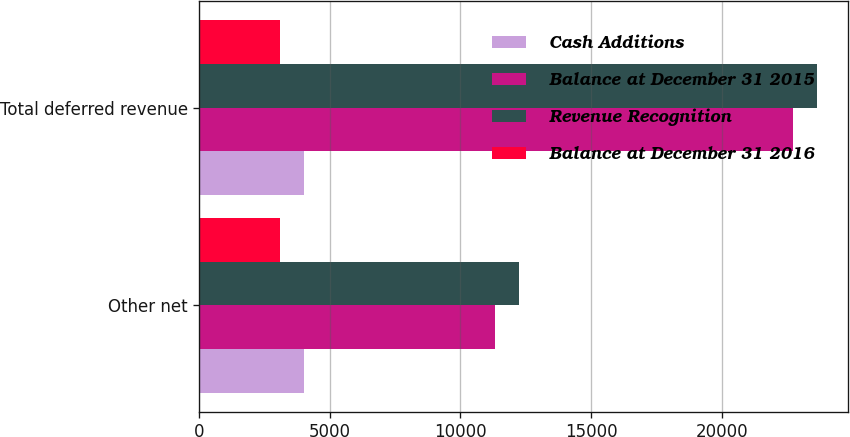<chart> <loc_0><loc_0><loc_500><loc_500><stacked_bar_chart><ecel><fcel>Other net<fcel>Total deferred revenue<nl><fcel>Cash Additions<fcel>4019<fcel>4019<nl><fcel>Balance at December 31 2015<fcel>11333<fcel>22733<nl><fcel>Revenue Recognition<fcel>12245<fcel>23645<nl><fcel>Balance at December 31 2016<fcel>3107<fcel>3107<nl></chart> 